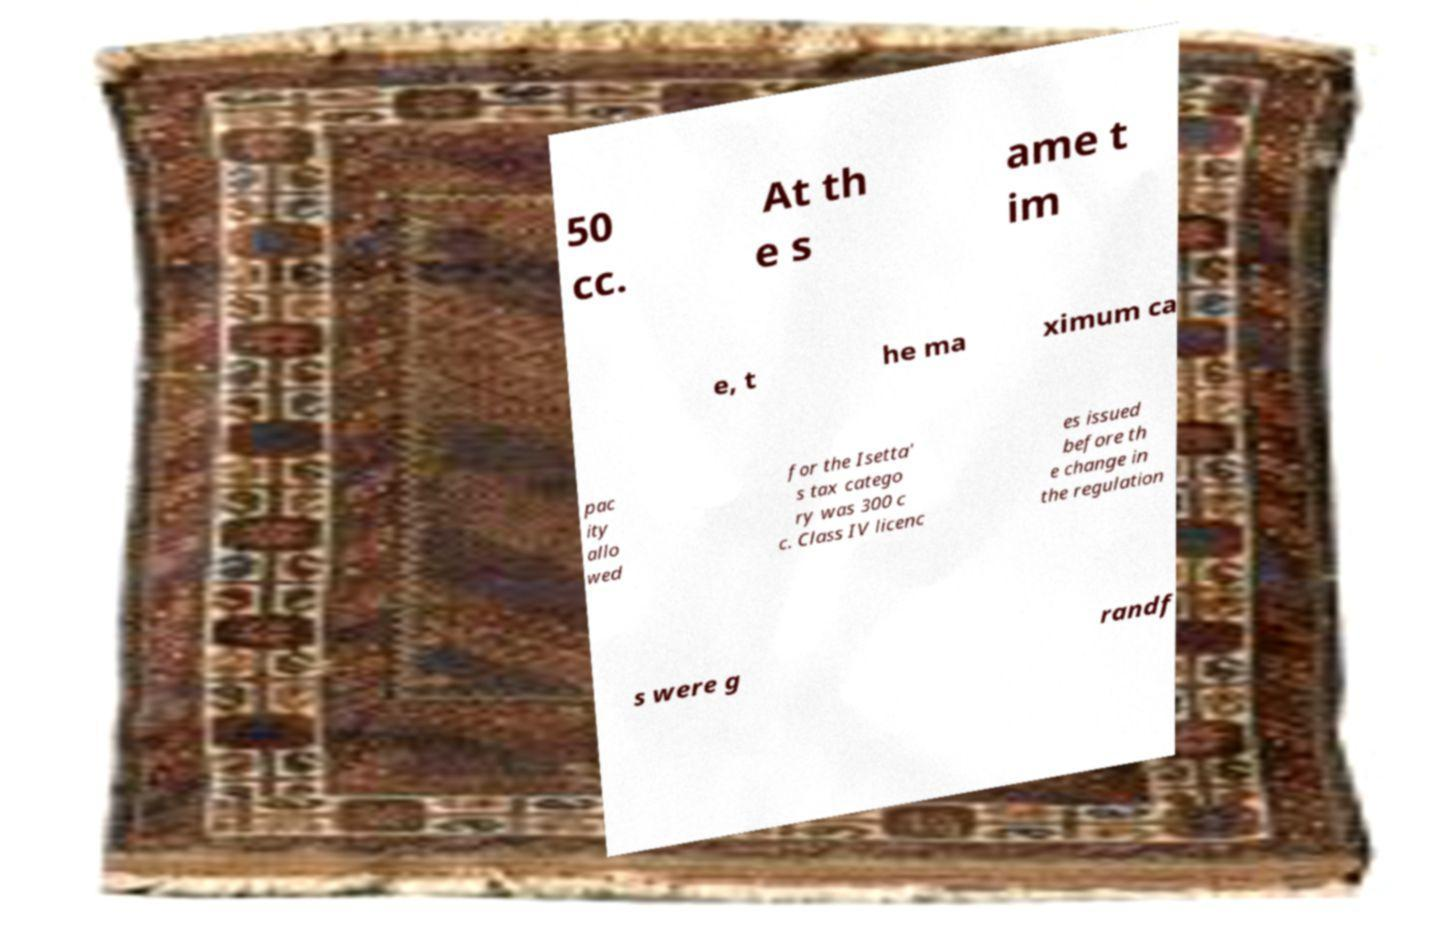There's text embedded in this image that I need extracted. Can you transcribe it verbatim? 50 cc. At th e s ame t im e, t he ma ximum ca pac ity allo wed for the Isetta' s tax catego ry was 300 c c. Class IV licenc es issued before th e change in the regulation s were g randf 